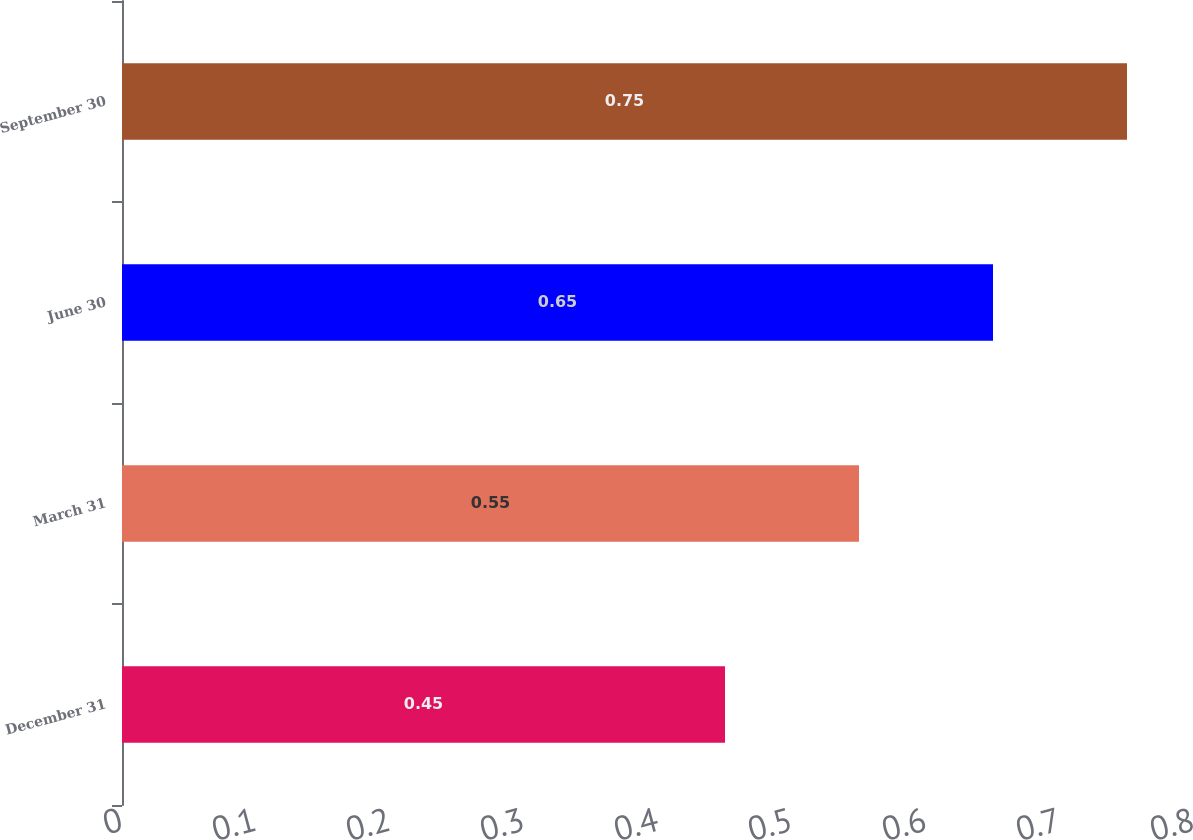Convert chart to OTSL. <chart><loc_0><loc_0><loc_500><loc_500><bar_chart><fcel>December 31<fcel>March 31<fcel>June 30<fcel>September 30<nl><fcel>0.45<fcel>0.55<fcel>0.65<fcel>0.75<nl></chart> 